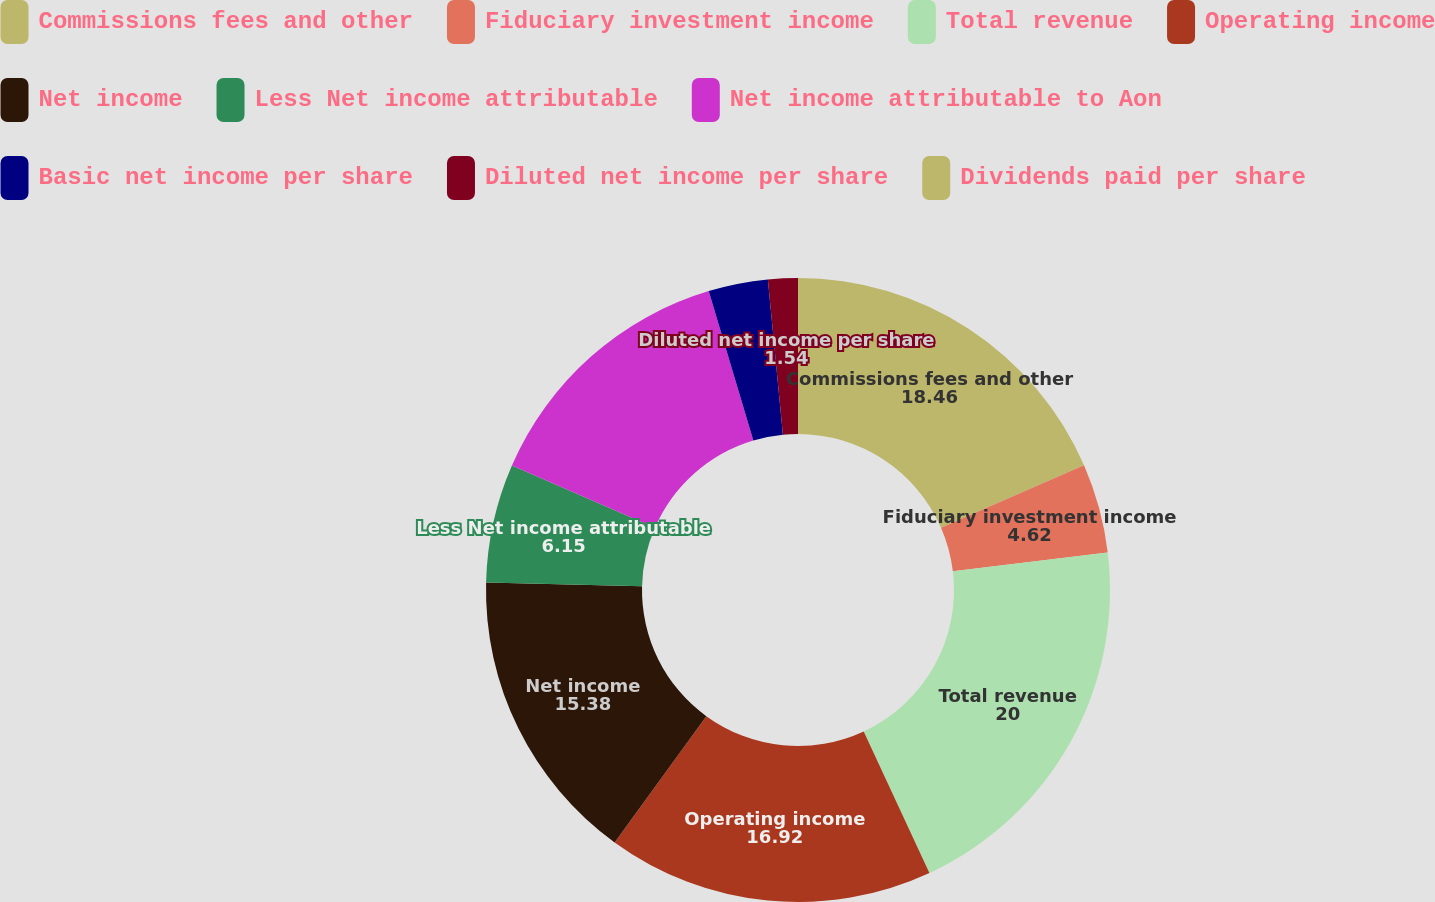<chart> <loc_0><loc_0><loc_500><loc_500><pie_chart><fcel>Commissions fees and other<fcel>Fiduciary investment income<fcel>Total revenue<fcel>Operating income<fcel>Net income<fcel>Less Net income attributable<fcel>Net income attributable to Aon<fcel>Basic net income per share<fcel>Diluted net income per share<fcel>Dividends paid per share<nl><fcel>18.46%<fcel>4.62%<fcel>20.0%<fcel>16.92%<fcel>15.38%<fcel>6.15%<fcel>13.85%<fcel>3.08%<fcel>1.54%<fcel>0.0%<nl></chart> 